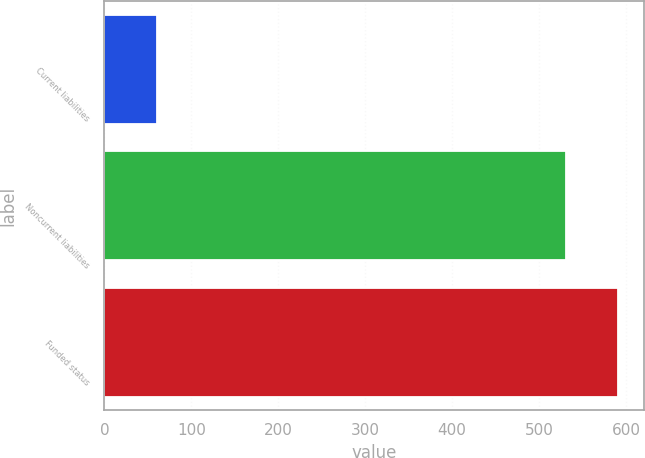<chart> <loc_0><loc_0><loc_500><loc_500><bar_chart><fcel>Current liabilities<fcel>Noncurrent liabilities<fcel>Funded status<nl><fcel>60<fcel>531<fcel>591<nl></chart> 